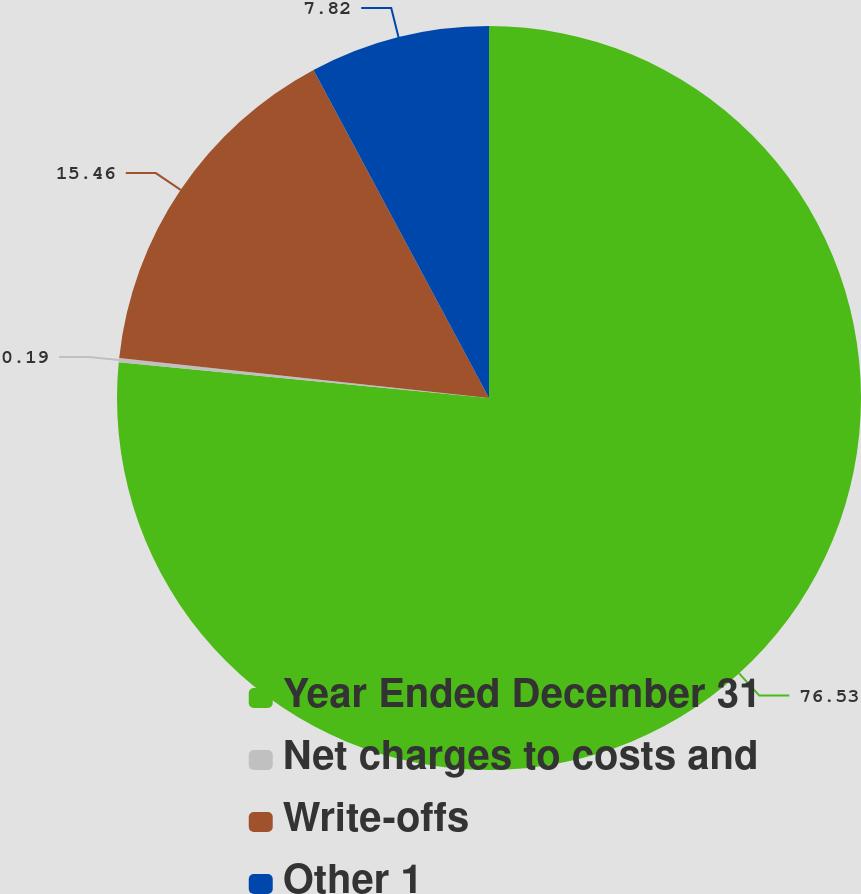Convert chart to OTSL. <chart><loc_0><loc_0><loc_500><loc_500><pie_chart><fcel>Year Ended December 31<fcel>Net charges to costs and<fcel>Write-offs<fcel>Other 1<nl><fcel>76.53%<fcel>0.19%<fcel>15.46%<fcel>7.82%<nl></chart> 